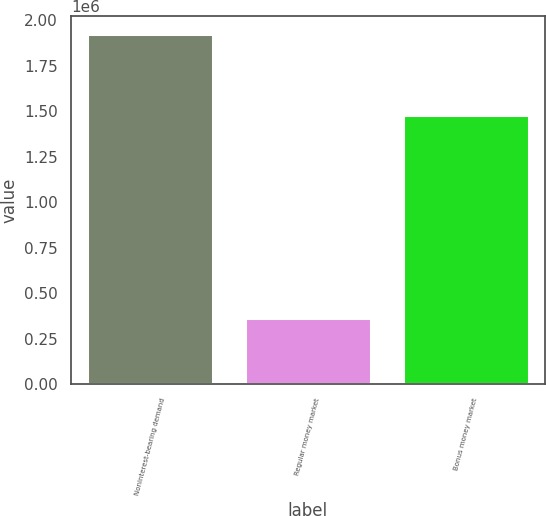Convert chart. <chart><loc_0><loc_0><loc_500><loc_500><bar_chart><fcel>Noninterest-bearing demand<fcel>Regular money market<fcel>Bonus money market<nl><fcel>1.9281e+06<fcel>363920<fcel>1.48146e+06<nl></chart> 